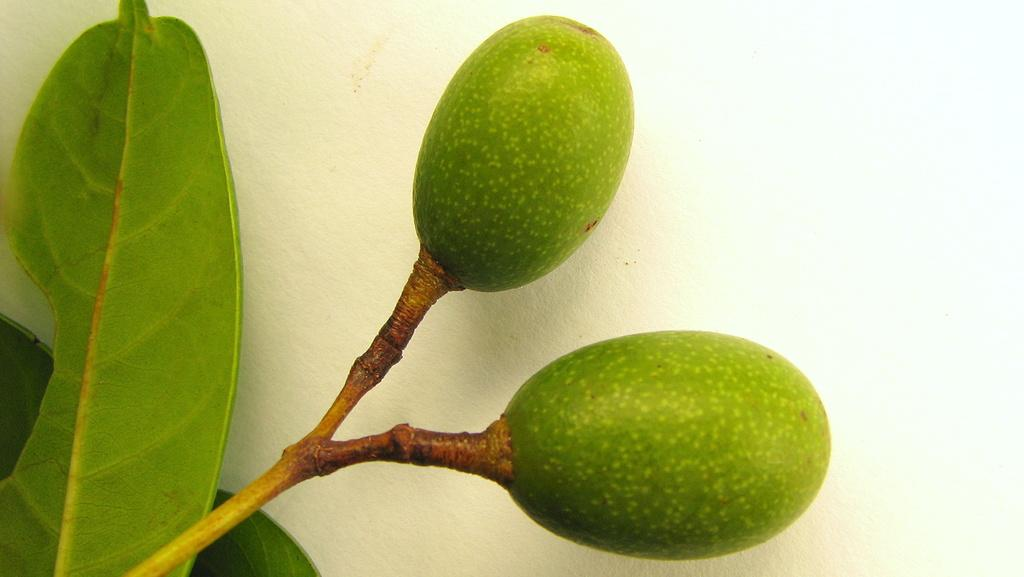What type of plant is visible in the image? There is a plant stem and leaves in the image. What can be seen on the plant? There are two green fruits on the plant. What is visible in the background of the image? There is a wall visible in the background of the image. What type of beast is hiding behind the plant in the image? There is no beast present in the image; it only features a plant with fruits and a wall in the background. 